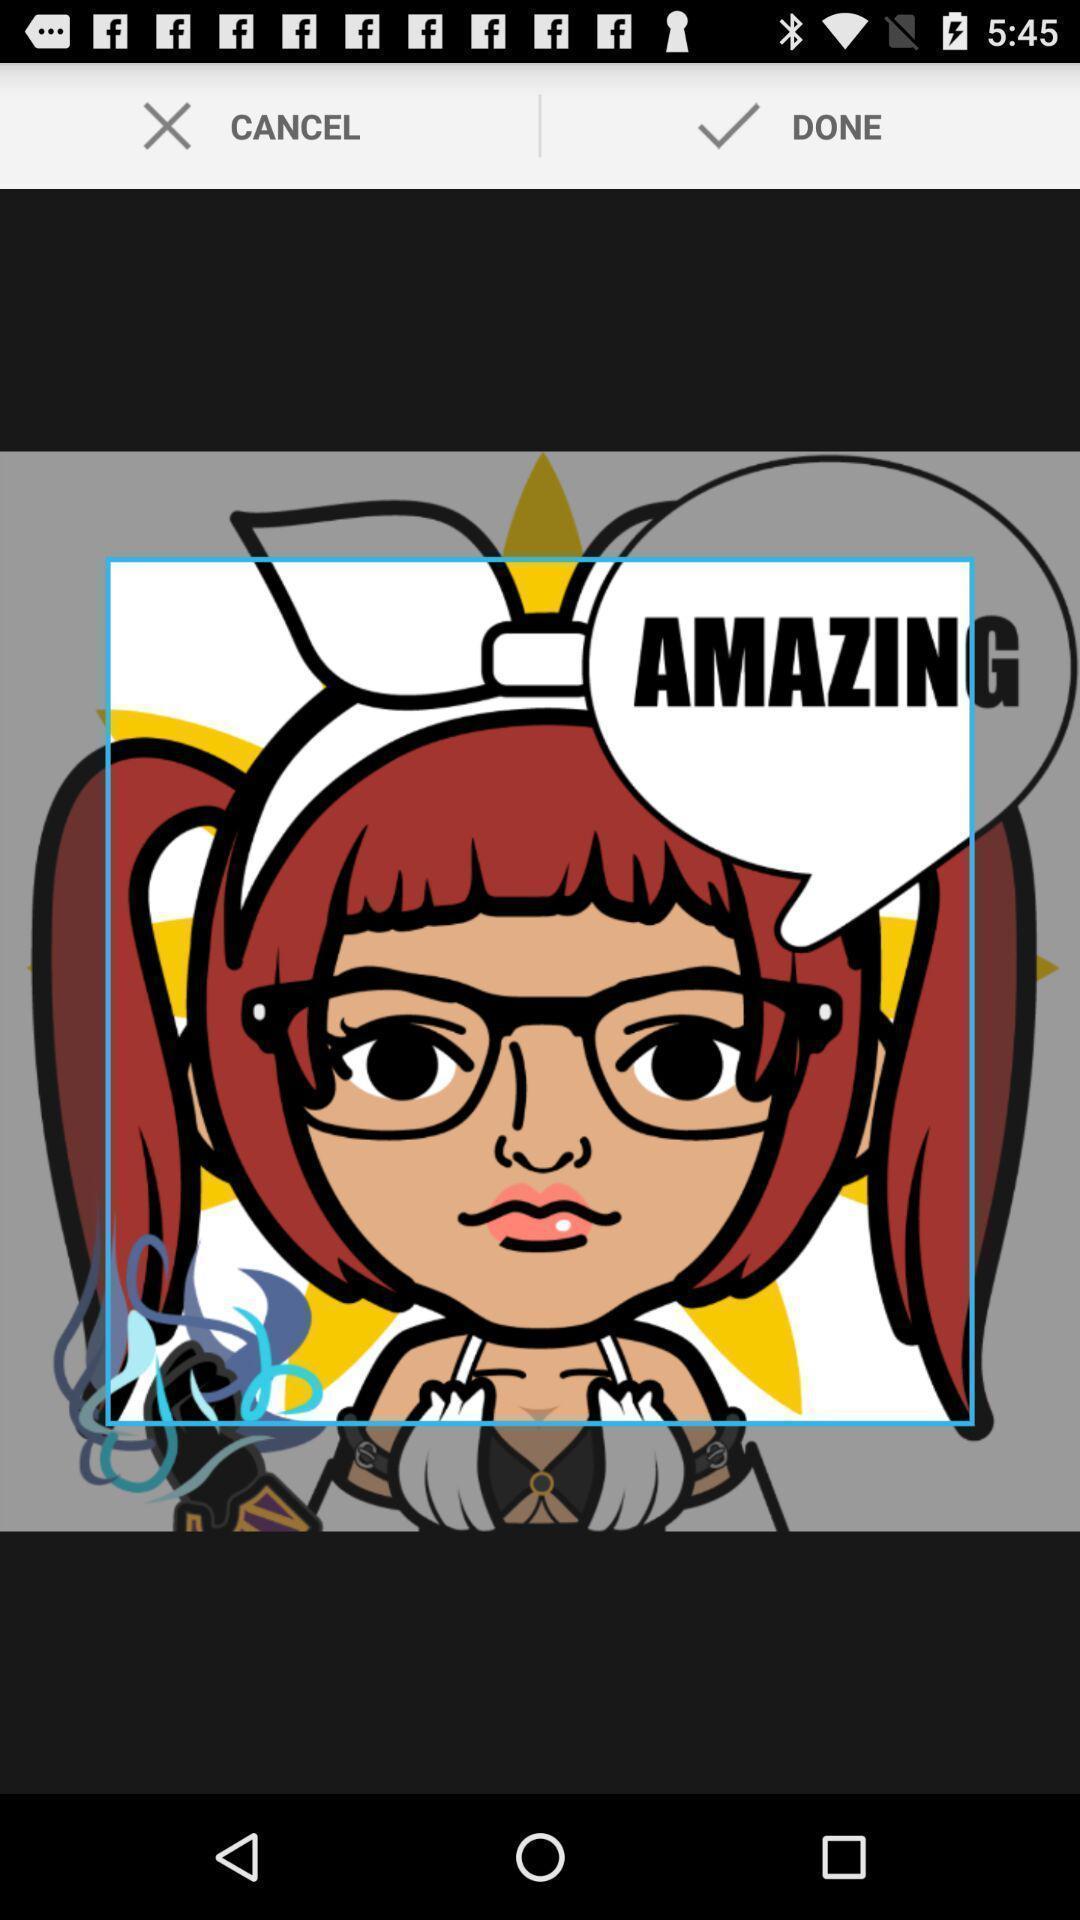Describe the content in this image. Page showing image. 